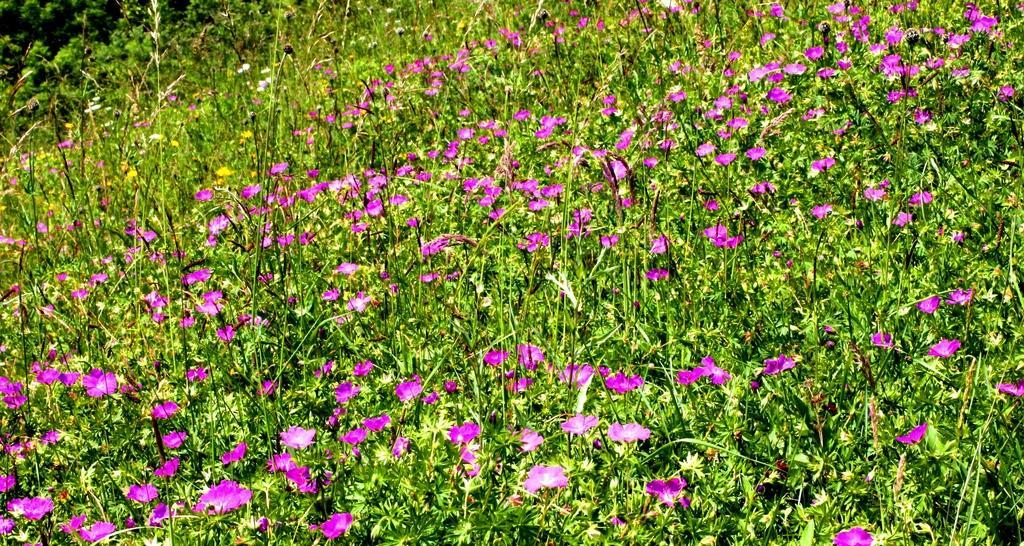How would you summarize this image in a sentence or two? This image is taken outdoors. In the background there are a few trees. In the middle of the image there are many plants with stems, green leaves and flowers. Those flowers are dark pink in color. 